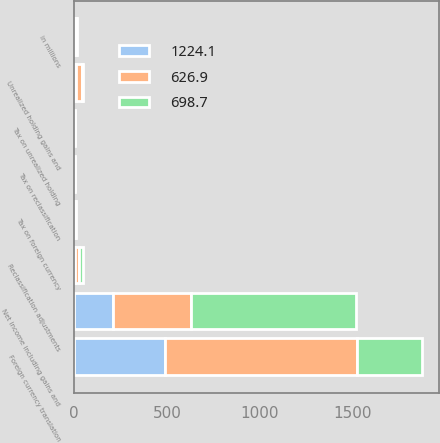Convert chart. <chart><loc_0><loc_0><loc_500><loc_500><stacked_bar_chart><ecel><fcel>in millions<fcel>Net income including gains and<fcel>Unrealized holding gains and<fcel>Tax on unrealized holding<fcel>Reclassification adjustments<fcel>Tax on reclassification<fcel>Foreign currency translation<fcel>Tax on foreign currency<nl><fcel>1224.1<fcel>5<fcel>209.3<fcel>10.6<fcel>2.8<fcel>4<fcel>1.1<fcel>488.3<fcel>0.7<nl><fcel>626.9<fcel>5<fcel>421<fcel>33.3<fcel>3.2<fcel>24<fcel>0.9<fcel>1034.2<fcel>5<nl><fcel>698.7<fcel>5<fcel>886.5<fcel>1<fcel>0.2<fcel>17.8<fcel>0.2<fcel>351.1<fcel>1.7<nl></chart> 